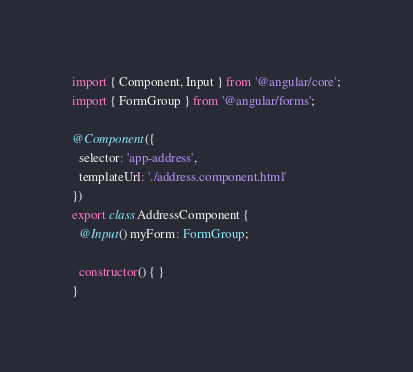Convert code to text. <code><loc_0><loc_0><loc_500><loc_500><_TypeScript_>import { Component, Input } from '@angular/core';
import { FormGroup } from '@angular/forms';

@Component({
  selector: 'app-address',
  templateUrl: './address.component.html'
})
export class AddressComponent {
  @Input() myForm: FormGroup;

  constructor() { }
}
</code> 